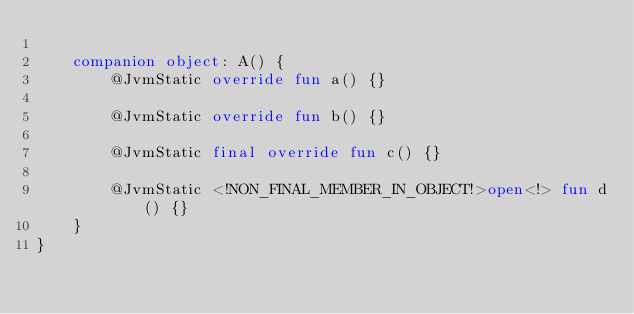Convert code to text. <code><loc_0><loc_0><loc_500><loc_500><_Kotlin_>
    companion object: A() {
        @JvmStatic override fun a() {}

        @JvmStatic override fun b() {}

        @JvmStatic final override fun c() {}

        @JvmStatic <!NON_FINAL_MEMBER_IN_OBJECT!>open<!> fun d() {}
    }
}</code> 